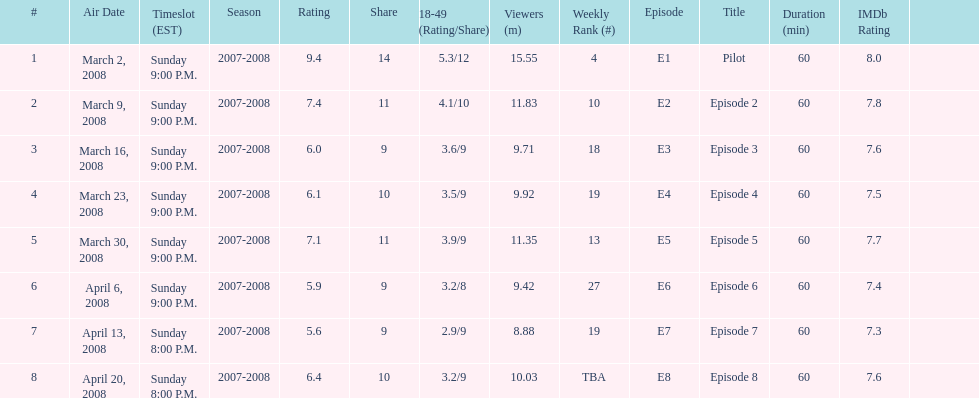The air date with the most viewers March 2, 2008. 